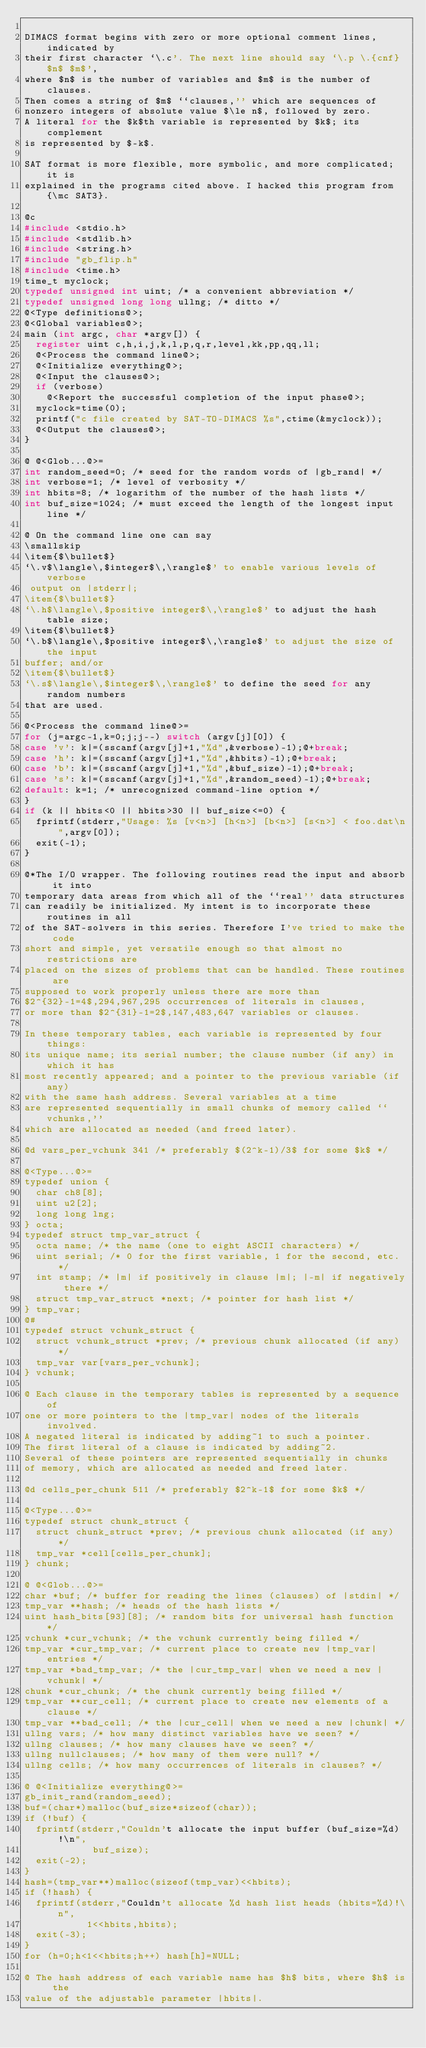<code> <loc_0><loc_0><loc_500><loc_500><_C_>
DIMACS format begins with zero or more optional comment lines, indicated by
their first character `\.c'. The next line should say `\.p \.{cnf} $n$ $m$',
where $n$ is the number of variables and $m$ is the number of clauses.
Then comes a string of $m$ ``clauses,'' which are sequences of
nonzero integers of absolute value $\le n$, followed by zero.
A literal for the $k$th variable is represented by $k$; its complement
is represented by $-k$.

SAT format is more flexible, more symbolic, and more complicated; it is
explained in the programs cited above. I hacked this program from {\mc SAT3}.

@c
#include <stdio.h>
#include <stdlib.h>
#include <string.h>
#include "gb_flip.h"
#include <time.h>
time_t myclock;
typedef unsigned int uint; /* a convenient abbreviation */
typedef unsigned long long ullng; /* ditto */
@<Type definitions@>;
@<Global variables@>;
main (int argc, char *argv[]) {
  register uint c,h,i,j,k,l,p,q,r,level,kk,pp,qq,ll;
  @<Process the command line@>;
  @<Initialize everything@>;
  @<Input the clauses@>;
  if (verbose)
    @<Report the successful completion of the input phase@>;
  myclock=time(0);
  printf("c file created by SAT-TO-DIMACS %s",ctime(&myclock));
  @<Output the clauses@>;
}

@ @<Glob...@>=
int random_seed=0; /* seed for the random words of |gb_rand| */
int verbose=1; /* level of verbosity */
int hbits=8; /* logarithm of the number of the hash lists */
int buf_size=1024; /* must exceed the length of the longest input line */

@ On the command line one can say
\smallskip
\item{$\bullet$}
`\.v$\langle\,$integer$\,\rangle$' to enable various levels of verbose
 output on |stderr|;
\item{$\bullet$}
`\.h$\langle\,$positive integer$\,\rangle$' to adjust the hash table size;
\item{$\bullet$}
`\.b$\langle\,$positive integer$\,\rangle$' to adjust the size of the input
buffer; and/or
\item{$\bullet$}
`\.s$\langle\,$integer$\,\rangle$' to define the seed for any random numbers
that are used.

@<Process the command line@>=
for (j=argc-1,k=0;j;j--) switch (argv[j][0]) {
case 'v': k|=(sscanf(argv[j]+1,"%d",&verbose)-1);@+break;
case 'h': k|=(sscanf(argv[j]+1,"%d",&hbits)-1);@+break;
case 'b': k|=(sscanf(argv[j]+1,"%d",&buf_size)-1);@+break;
case 's': k|=(sscanf(argv[j]+1,"%d",&random_seed)-1);@+break;
default: k=1; /* unrecognized command-line option */
}
if (k || hbits<0 || hbits>30 || buf_size<=0) {
  fprintf(stderr,"Usage: %s [v<n>] [h<n>] [b<n>] [s<n>] < foo.dat\n",argv[0]);
  exit(-1);
}

@*The I/O wrapper. The following routines read the input and absorb it into
temporary data areas from which all of the ``real'' data structures
can readily be initialized. My intent is to incorporate these routines in all
of the SAT-solvers in this series. Therefore I've tried to make the code
short and simple, yet versatile enough so that almost no restrictions are
placed on the sizes of problems that can be handled. These routines are
supposed to work properly unless there are more than
$2^{32}-1=4$,294,967,295 occurrences of literals in clauses,
or more than $2^{31}-1=2$,147,483,647 variables or clauses.

In these temporary tables, each variable is represented by four things:
its unique name; its serial number; the clause number (if any) in which it has
most recently appeared; and a pointer to the previous variable (if any)
with the same hash address. Several variables at a time
are represented sequentially in small chunks of memory called ``vchunks,''
which are allocated as needed (and freed later).

@d vars_per_vchunk 341 /* preferably $(2^k-1)/3$ for some $k$ */

@<Type...@>=
typedef union {
  char ch8[8];
  uint u2[2];
  long long lng;
} octa;
typedef struct tmp_var_struct {
  octa name; /* the name (one to eight ASCII characters) */
  uint serial; /* 0 for the first variable, 1 for the second, etc. */
  int stamp; /* |m| if positively in clause |m|; |-m| if negatively there */
  struct tmp_var_struct *next; /* pointer for hash list */
} tmp_var;
@#
typedef struct vchunk_struct {
  struct vchunk_struct *prev; /* previous chunk allocated (if any) */
  tmp_var var[vars_per_vchunk];
} vchunk;

@ Each clause in the temporary tables is represented by a sequence of
one or more pointers to the |tmp_var| nodes of the literals involved.
A negated literal is indicated by adding~1 to such a pointer.
The first literal of a clause is indicated by adding~2.
Several of these pointers are represented sequentially in chunks
of memory, which are allocated as needed and freed later.

@d cells_per_chunk 511 /* preferably $2^k-1$ for some $k$ */

@<Type...@>=
typedef struct chunk_struct {
  struct chunk_struct *prev; /* previous chunk allocated (if any) */
  tmp_var *cell[cells_per_chunk];
} chunk;

@ @<Glob...@>=
char *buf; /* buffer for reading the lines (clauses) of |stdin| */
tmp_var **hash; /* heads of the hash lists */
uint hash_bits[93][8]; /* random bits for universal hash function */
vchunk *cur_vchunk; /* the vchunk currently being filled */
tmp_var *cur_tmp_var; /* current place to create new |tmp_var| entries */
tmp_var *bad_tmp_var; /* the |cur_tmp_var| when we need a new |vchunk| */
chunk *cur_chunk; /* the chunk currently being filled */
tmp_var **cur_cell; /* current place to create new elements of a clause */
tmp_var **bad_cell; /* the |cur_cell| when we need a new |chunk| */
ullng vars; /* how many distinct variables have we seen? */
ullng clauses; /* how many clauses have we seen? */
ullng nullclauses; /* how many of them were null? */
ullng cells; /* how many occurrences of literals in clauses? */

@ @<Initialize everything@>=
gb_init_rand(random_seed);
buf=(char*)malloc(buf_size*sizeof(char));
if (!buf) {
  fprintf(stderr,"Couldn't allocate the input buffer (buf_size=%d)!\n",
            buf_size);
  exit(-2);
}
hash=(tmp_var**)malloc(sizeof(tmp_var)<<hbits);
if (!hash) {
  fprintf(stderr,"Couldn't allocate %d hash list heads (hbits=%d)!\n",
           1<<hbits,hbits);
  exit(-3);
}
for (h=0;h<1<<hbits;h++) hash[h]=NULL;

@ The hash address of each variable name has $h$ bits, where $h$ is the
value of the adjustable parameter |hbits|.</code> 